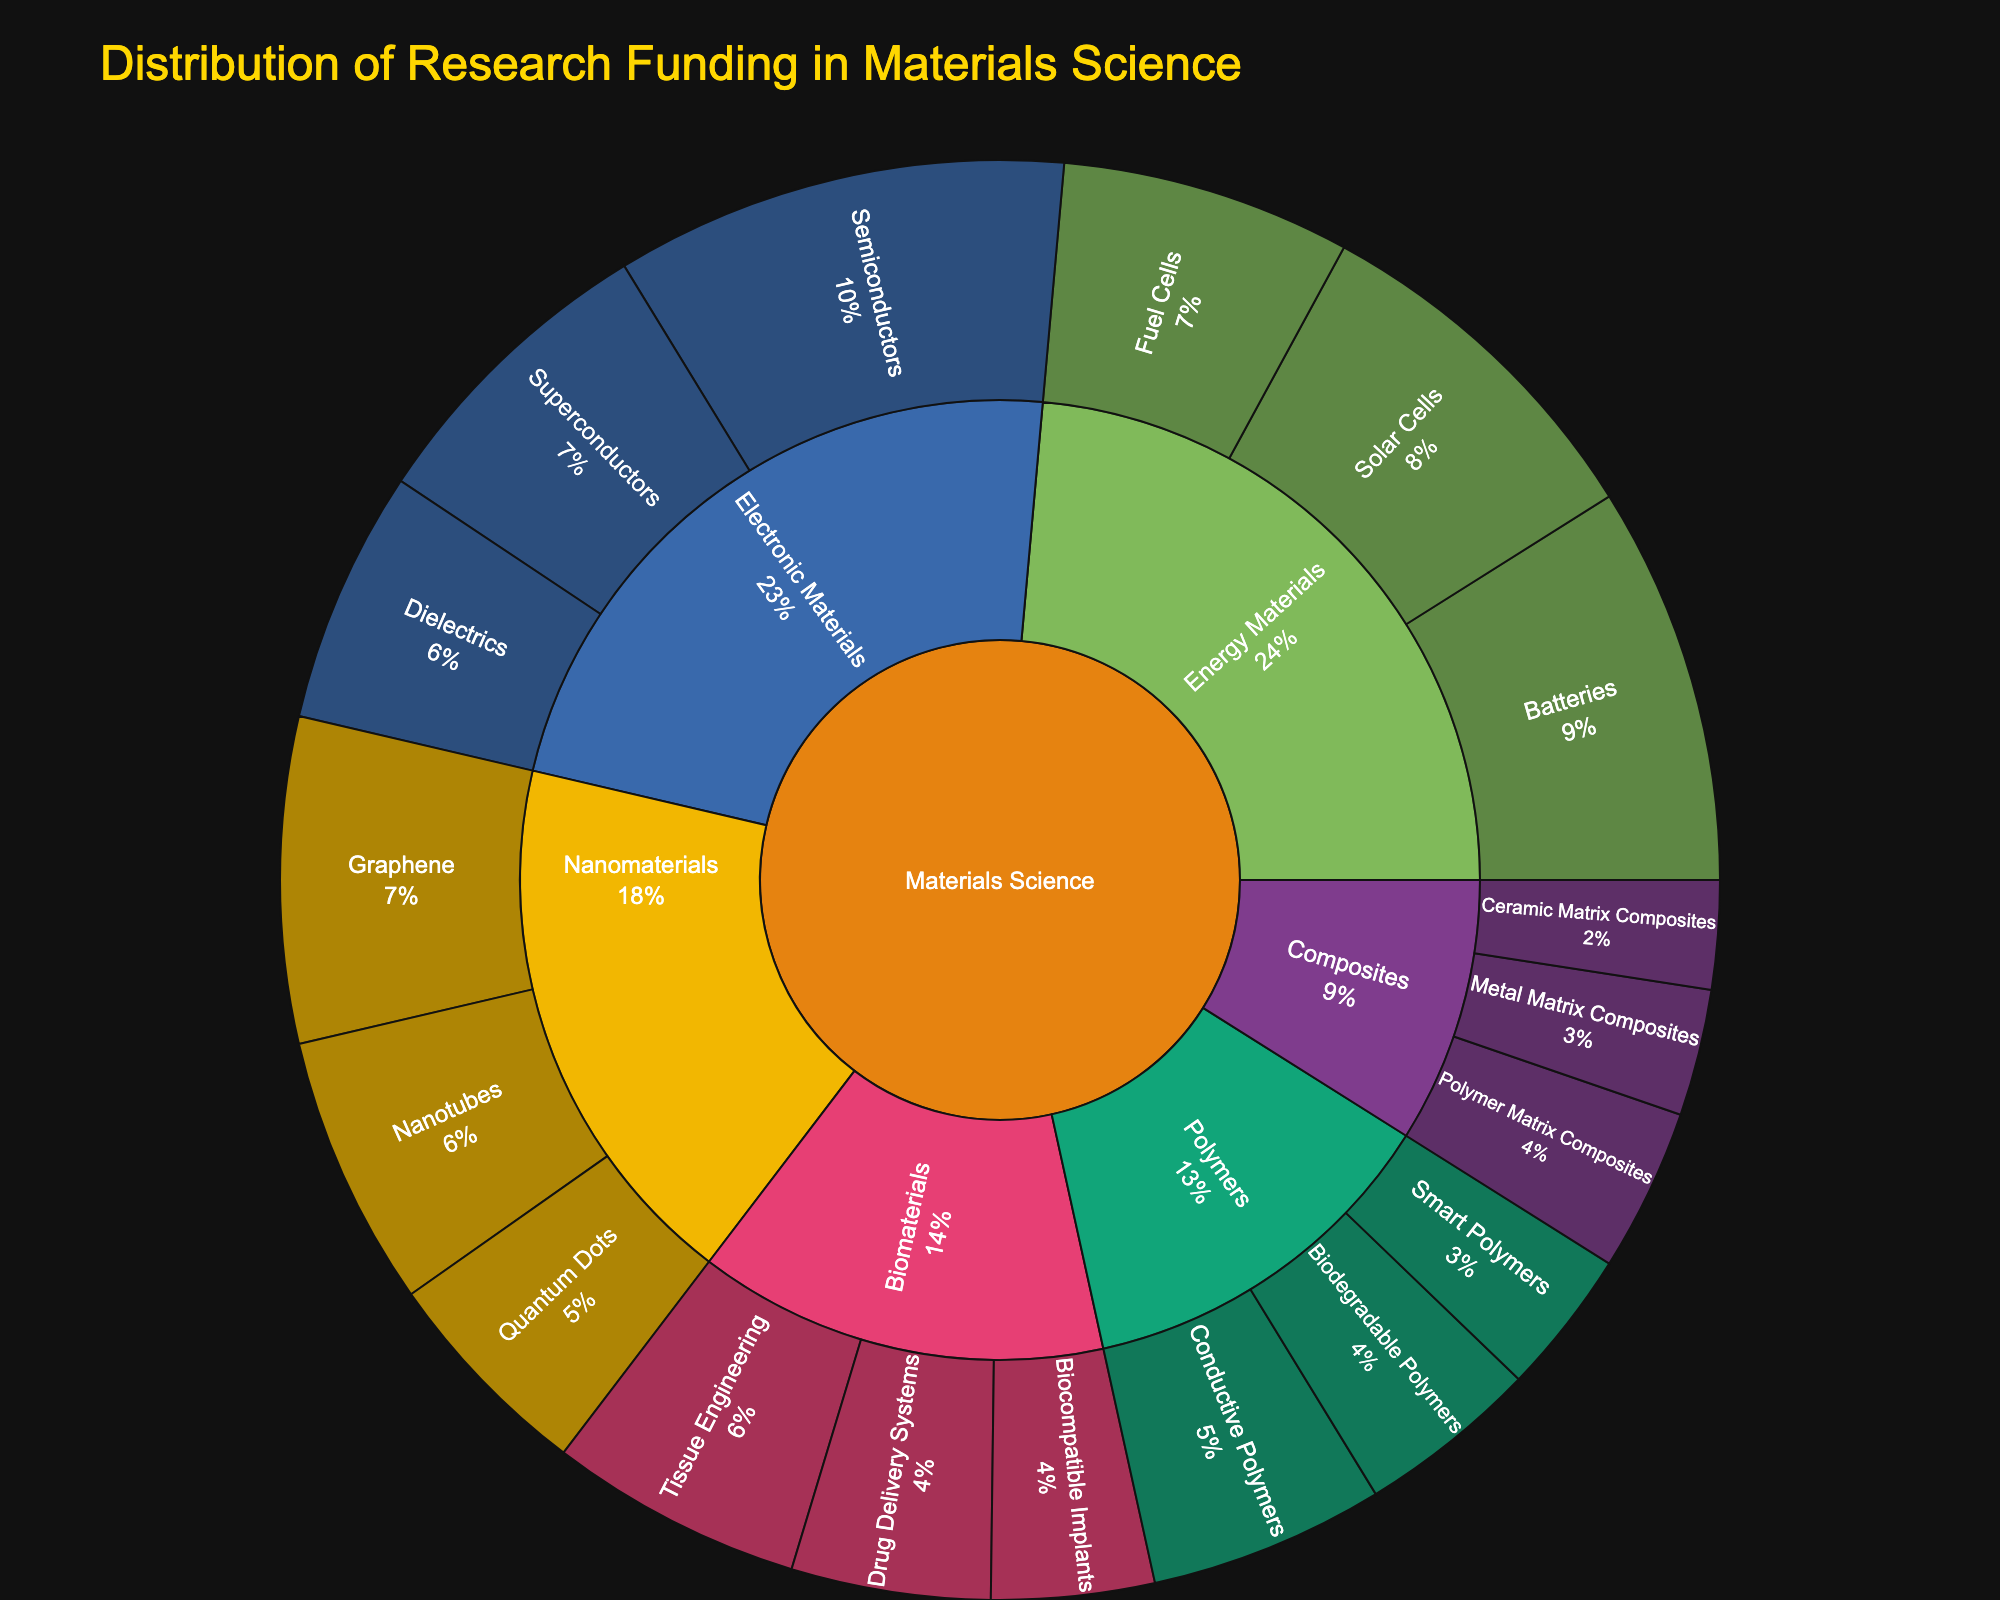What's the total funding allocated to Nanomaterials? To find the total funding allocated to Nanomaterials, look at the sum of the values associated with its subcategories: Nanotubes (15), Quantum Dots (12), and Graphene (18). Sum these values: 15 + 12 + 18 = 45.
Answer: 45 Which subcategory within Electronic Materials received the highest funding? Among the subcategories of Electronic Materials, compare the funding values: Semiconductors (25), Superconductors (17), and Dielectrics (14). The highest value is for Semiconductors.
Answer: Semiconductors Is the funding for Biomaterials higher or lower than the funding for Energy Materials? Sum the funding for Biomaterials subcategories (Tissue Engineering: 14, Drug Delivery Systems: 11, Biocompatible Implants: 9) to get 14 + 11 + 9 = 34. Do the same for Energy Materials subcategories (Solar Cells: 20, Batteries: 22, Fuel Cells: 16) to get 20 + 22 + 16 = 58. Compare these totals: 34 is less than 58, so the funding for Biomaterials is lower.
Answer: Lower How much more funding is allocated to Batteries compared to Drug Delivery Systems? Reference the values: Batteries (22) and Drug Delivery Systems (11). Compute the difference: 22 - 11 = 11.
Answer: 11 What percentage of the total funding is allocated to the Semiconductors subsubcategory? First, calculate the total funding by summing the values of all subcategories: 15 + 12 + 18 + 14 + 11 + 9 + 20 + 22 + 16 + 13 + 10 + 8 + 7 + 6 + 9 + 25 + 17 + 14 = 236. The funding for Semiconductors is 25. Calculate the percentage: (25 / 236) * 100 ≈ 10.59%.
Answer: Approximately 10.59% Which subcategory within Composites received the lowest funding? Among the subcategories of Composites, compare the funding values: Metal Matrix Composites (7), Ceramic Matrix Composites (6), and Polymer Matrix Composites (9). The lowest value is for Ceramic Matrix Composites.
Answer: Ceramic Matrix Composites What proportion of the research funding in Energy Materials is allocated to Solar Cells? Total funding in Energy Materials is the sum of its subcategories: Solar Cells (20), Batteries (22), and Fuel Cells (16), totaling 20 + 22 + 16 = 58. The funding for Solar Cells is 20. Compute the proportion: 20 / 58 ≈ 0.345 or 34.5%.
Answer: Approximately 34.5% Is the overall funding for Polymers closer to that of Nanomaterials or Biomaterials? Compute the total for Polymers (Conductive Polymers: 13, Biodegradable Polymers: 10, Smart Polymers: 8) to get 13 + 10 + 8 = 31. Compare to Nanomaterials (15 + 12 + 18 = 45) and Biomaterials (14 + 11 + 9 = 34). The funding for Polymers (31) is closer to Biomaterials (34) than to Nanomaterials (45).
Answer: Biomaterials 